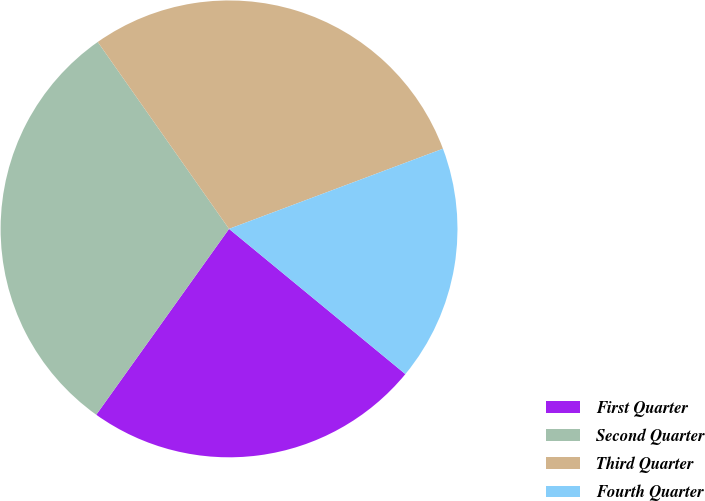Convert chart. <chart><loc_0><loc_0><loc_500><loc_500><pie_chart><fcel>First Quarter<fcel>Second Quarter<fcel>Third Quarter<fcel>Fourth Quarter<nl><fcel>23.91%<fcel>30.38%<fcel>29.04%<fcel>16.67%<nl></chart> 